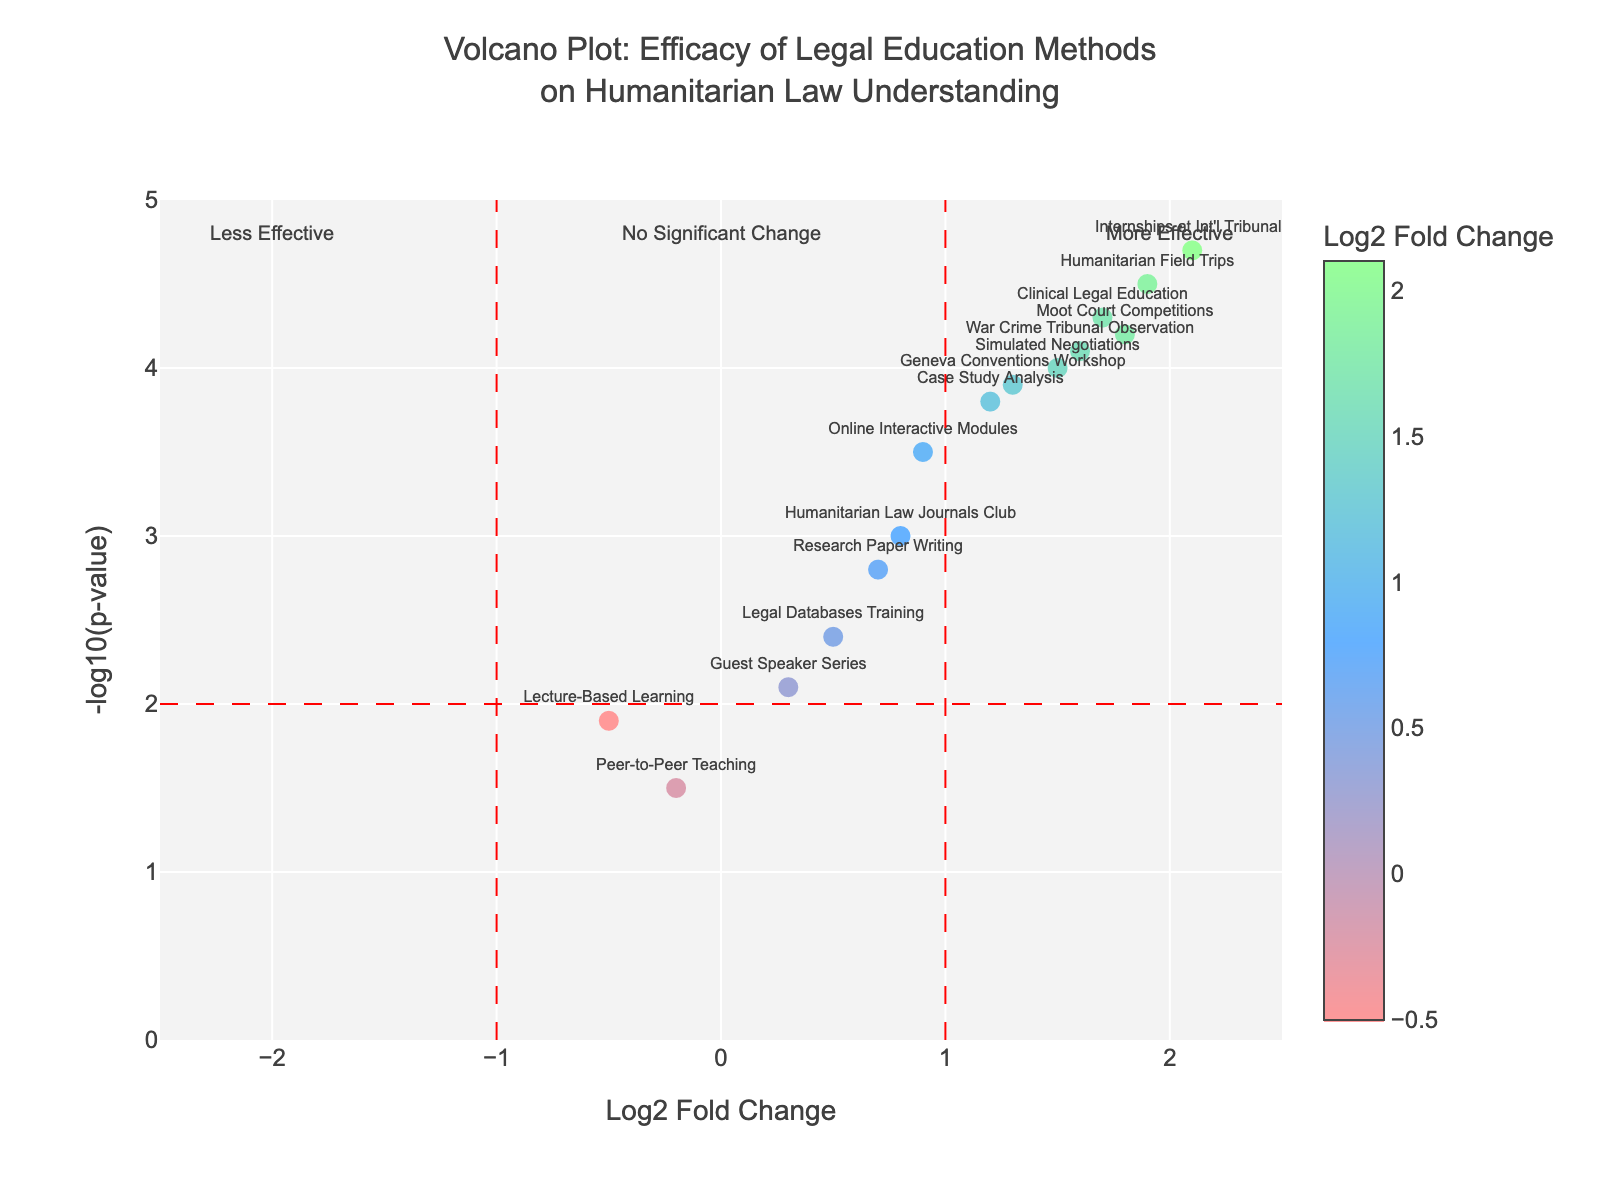what is the title of the plot? The title of the plot is located at the top and reads: "Volcano Plot: Efficacy of Legal Education Methods on Humanitarian Law Understanding".
Answer: Volcano Plot: Efficacy of Legal Education Methods on Humanitarian Law Understanding What are the axes titles of the plot? The x-axis is titled "Log2 Fold Change" and the y-axis is titled "-log10(p-value)" as indicated next to each respective axis.
Answer: Log2 Fold Change and -log10(p-value) How many data points have a negative Log2 Fold Change? To find this, count the data points that appear on the left side of the zero line on the x-axis. According to the visual plot, there are 2 data points on the negative side of the Log2 Fold Change.
Answer: 2 Which method has the highest negative Log2 Fold Change, and what is its -log10(p-value)? Look at the left side of the x-axis for the lowest value and correlate it with the plotted methods. The method "Lecture-Based Learning" has the highest negative Log2 Fold Change with a value of -0.5, and its -log10(p-value) is 1.9.
Answer: Lecture-Based Learning, 1.9 What is the relationship between "Internships at Int'l Tribunals" and "Humanitarian Field Trips" in terms of Log2 Fold Change? Compare the Log2 Fold Change of both methods. "Internships at Int'l Tribunals" has a Log2 Fold Change of 2.1, while "Humanitarian Field Trips" has a Log2 Fold Change of 1.9. Thus, Internships have a higher Log2 Fold Change.
Answer: Internships at Int'l Tribunals > Humanitarian Field Trips What can you infer about the methods plotted in the upper-right quadrant of the plot? The upper-right quadrant contains methods with positive Log2 Fold Change values and high -log10(p-value) values, indicating they are more effective and statistically significant. Methods here include "Internships at Int'l Tribunals," "Humanitarian Field Trips," "Clinical Legal Education," etc.
Answer: More effective and statistically significant Which method has both the highest Log2 Fold Change and the highest -log10(p-value)? Analyze the plot to find the method plotting the farthest to the right and the highest up. "Internships at Int'l Tribunals" has the highest values for both axes.
Answer: Internships at Int'l Tribunals Are there any methods that show no significant change? Which are they? Look around the y-axis value of 2, since statistical significance is typically considered at -log10(p-value) >= 2.0. Methods below or around that line, especially near the zero x-axis, include "Lecture-Based Learning," and "Peer-to-Peer Teaching".
Answer: Lecture-Based Learning, Peer-to-Peer Teaching 